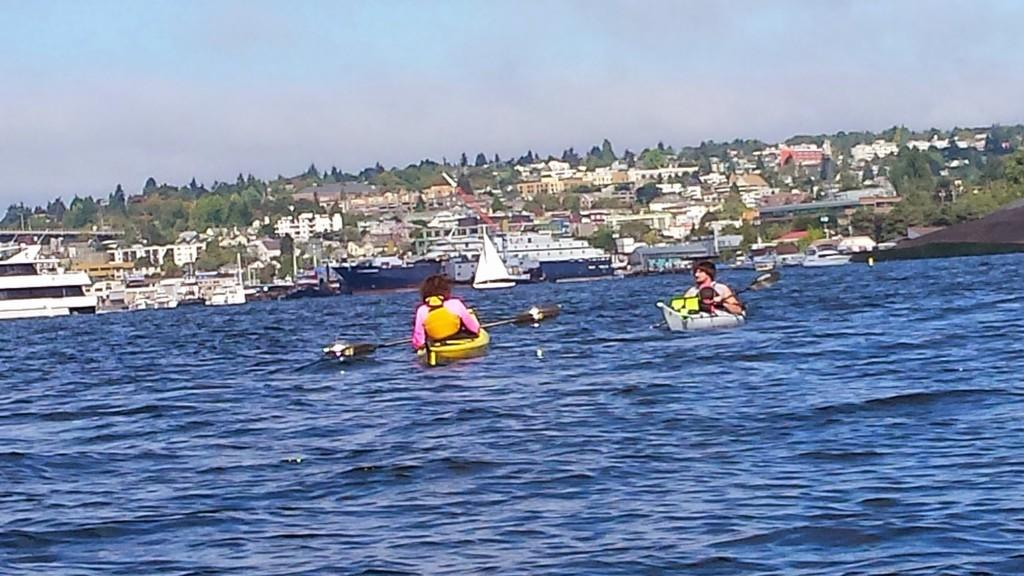How many people are in the image? There are two persons in the image. What are the persons doing in the image? The persons are floating on individual boats. Where are the boats located? The boats are on a river. What can be seen in the background of the image? There are buildings, trees, and the sky visible in the background of the image. What type of soda is being served on the front boat in the image? There is no soda present in the image; the persons are floating on individual boats on a river. Can you see a rabbit hopping near the trees in the background of the image? There is no rabbit visible in the image; only buildings, trees, and the sky are present in the background. 